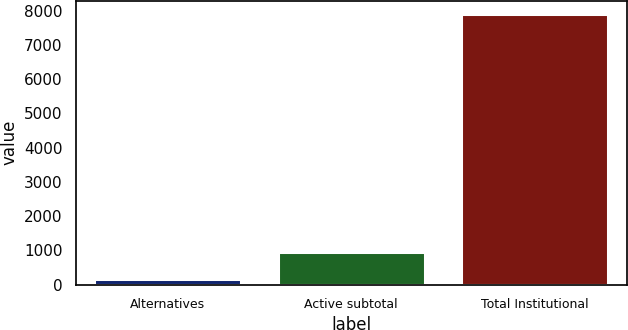Convert chart. <chart><loc_0><loc_0><loc_500><loc_500><bar_chart><fcel>Alternatives<fcel>Active subtotal<fcel>Total Institutional<nl><fcel>175<fcel>947.5<fcel>7900<nl></chart> 